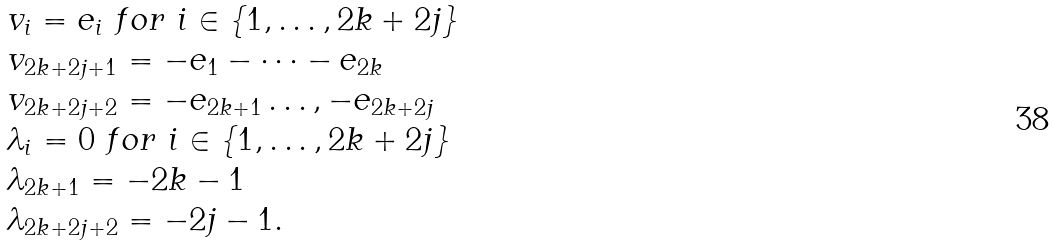Convert formula to latex. <formula><loc_0><loc_0><loc_500><loc_500>\begin{array} { l } v _ { i } = e _ { i } \ f o r \ i \in \{ 1 , \dots , 2 k + 2 j \} \\ v _ { 2 k + 2 j + 1 } = - e _ { 1 } - \dots - e _ { 2 k } \\ v _ { 2 k + 2 j + 2 } = - e _ { 2 k + 1 } \dots , - e _ { 2 k + 2 j } \\ \lambda _ { i } = 0 \ f o r \ i \in \{ 1 , \dots , 2 k + 2 j \} \\ \lambda _ { 2 k + 1 } = - 2 k - 1 \\ \lambda _ { 2 k + 2 j + 2 } = - 2 j - 1 . \end{array}</formula> 